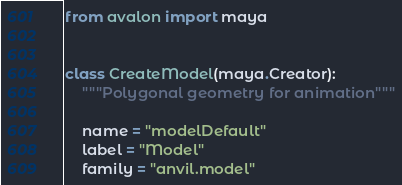<code> <loc_0><loc_0><loc_500><loc_500><_Python_>from avalon import maya


class CreateModel(maya.Creator):
    """Polygonal geometry for animation"""

    name = "modelDefault"
    label = "Model"
    family = "anvil.model"
</code> 